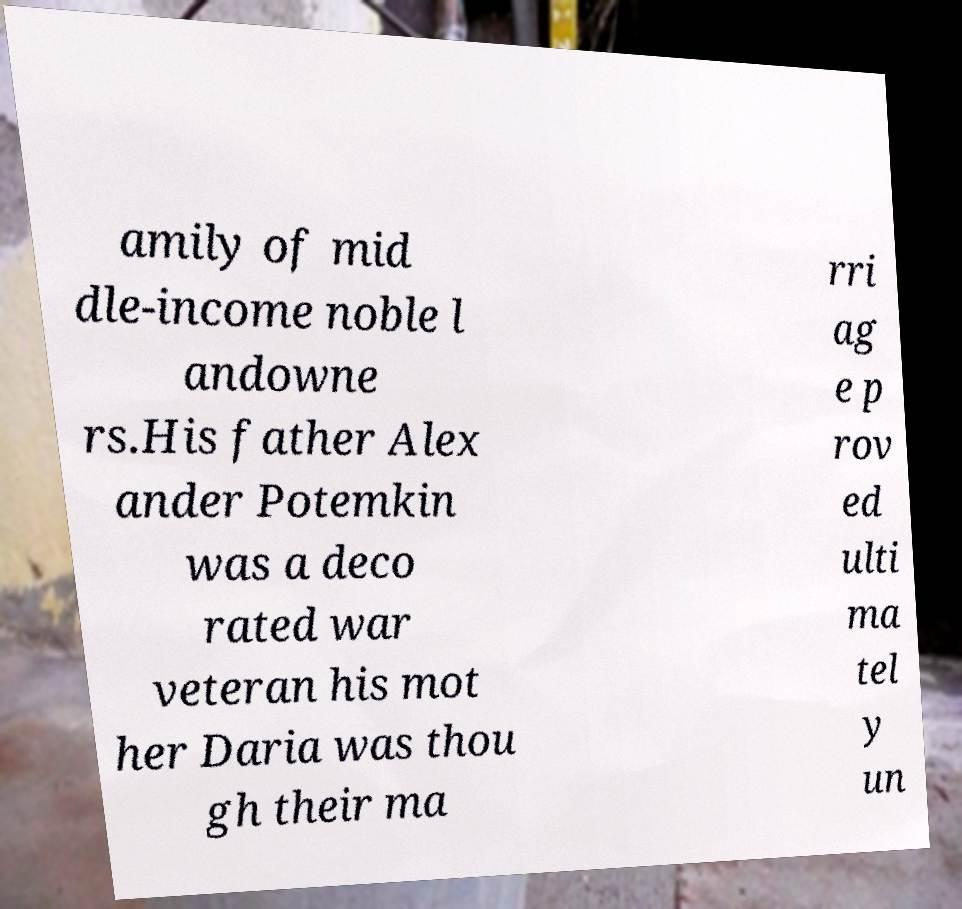Please identify and transcribe the text found in this image. amily of mid dle-income noble l andowne rs.His father Alex ander Potemkin was a deco rated war veteran his mot her Daria was thou gh their ma rri ag e p rov ed ulti ma tel y un 